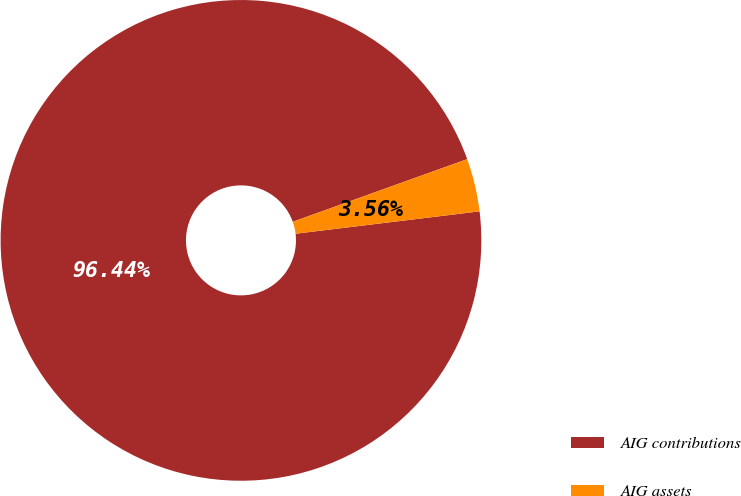Convert chart. <chart><loc_0><loc_0><loc_500><loc_500><pie_chart><fcel>AIG contributions<fcel>AIG assets<nl><fcel>96.44%<fcel>3.56%<nl></chart> 